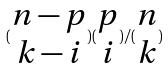Convert formula to latex. <formula><loc_0><loc_0><loc_500><loc_500>( \begin{matrix} n - p \\ k - i \end{matrix} ) ( \begin{matrix} p \\ i \end{matrix} ) / ( \begin{matrix} n \\ k \end{matrix} )</formula> 